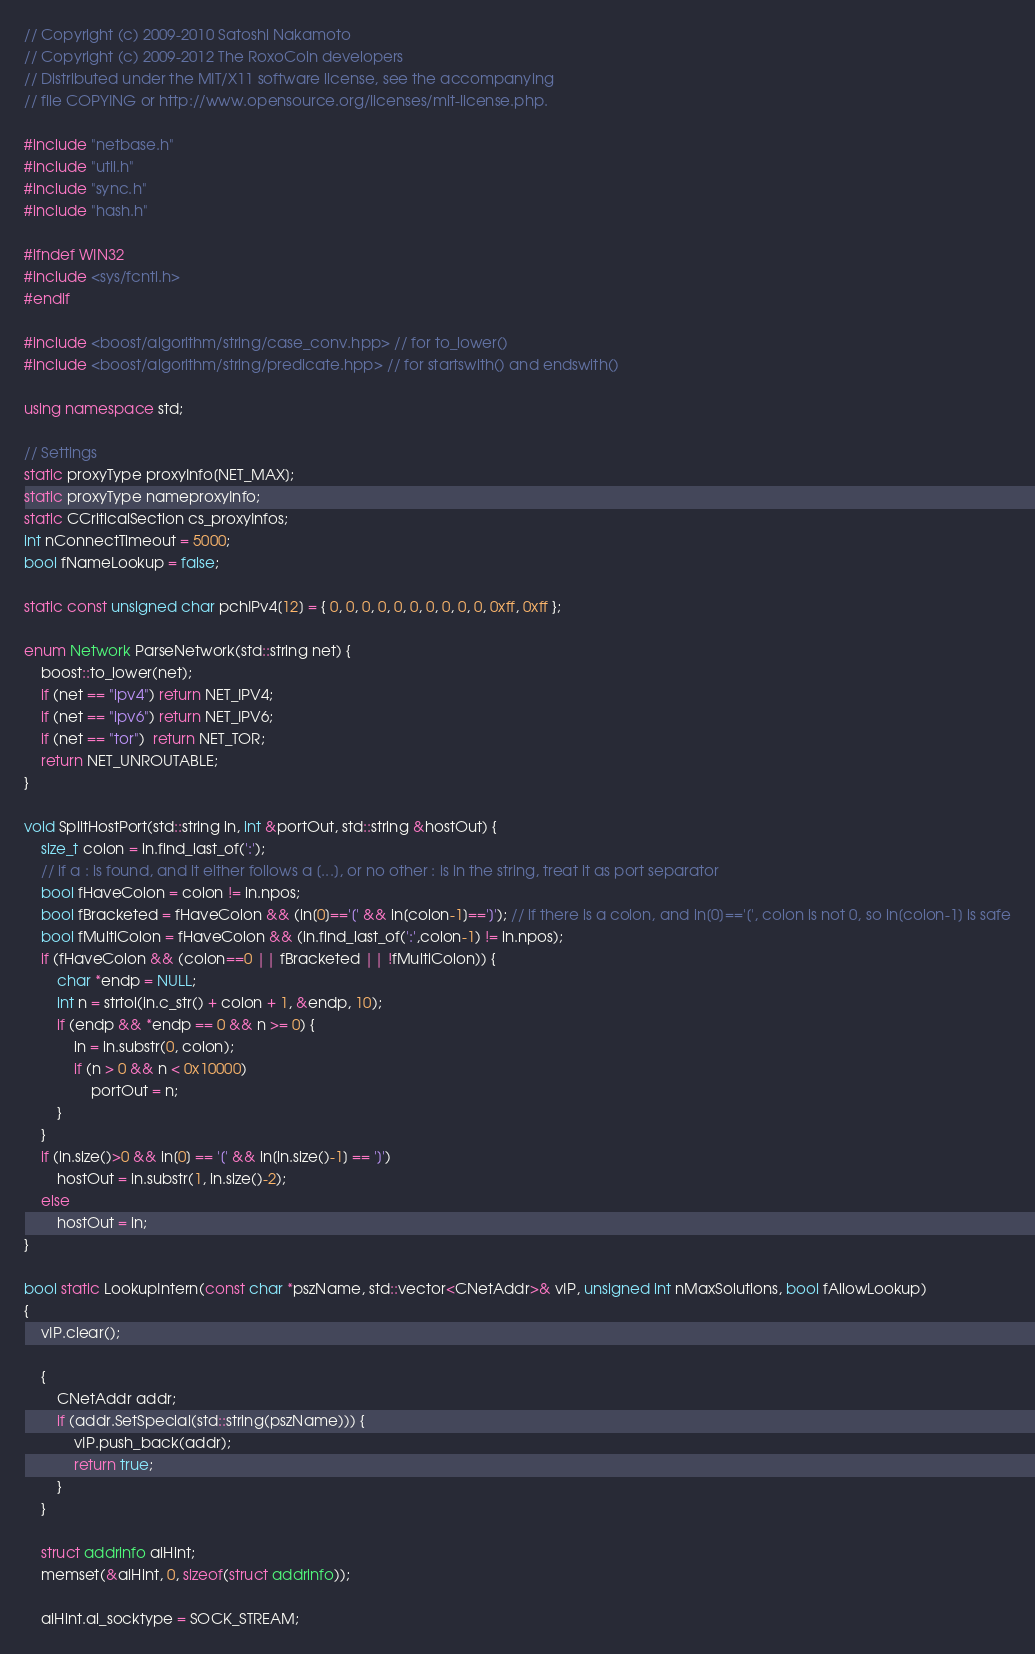Convert code to text. <code><loc_0><loc_0><loc_500><loc_500><_C++_>// Copyright (c) 2009-2010 Satoshi Nakamoto
// Copyright (c) 2009-2012 The RoxoCoin developers
// Distributed under the MIT/X11 software license, see the accompanying
// file COPYING or http://www.opensource.org/licenses/mit-license.php.

#include "netbase.h"
#include "util.h"
#include "sync.h"
#include "hash.h"

#ifndef WIN32
#include <sys/fcntl.h>
#endif

#include <boost/algorithm/string/case_conv.hpp> // for to_lower()
#include <boost/algorithm/string/predicate.hpp> // for startswith() and endswith()

using namespace std;

// Settings
static proxyType proxyInfo[NET_MAX];
static proxyType nameproxyInfo;
static CCriticalSection cs_proxyInfos;
int nConnectTimeout = 5000;
bool fNameLookup = false;

static const unsigned char pchIPv4[12] = { 0, 0, 0, 0, 0, 0, 0, 0, 0, 0, 0xff, 0xff };

enum Network ParseNetwork(std::string net) {
    boost::to_lower(net);
    if (net == "ipv4") return NET_IPV4;
    if (net == "ipv6") return NET_IPV6;
    if (net == "tor")  return NET_TOR;
    return NET_UNROUTABLE;
}

void SplitHostPort(std::string in, int &portOut, std::string &hostOut) {
    size_t colon = in.find_last_of(':');
    // if a : is found, and it either follows a [...], or no other : is in the string, treat it as port separator
    bool fHaveColon = colon != in.npos;
    bool fBracketed = fHaveColon && (in[0]=='[' && in[colon-1]==']'); // if there is a colon, and in[0]=='[', colon is not 0, so in[colon-1] is safe
    bool fMultiColon = fHaveColon && (in.find_last_of(':',colon-1) != in.npos);
    if (fHaveColon && (colon==0 || fBracketed || !fMultiColon)) {
        char *endp = NULL;
        int n = strtol(in.c_str() + colon + 1, &endp, 10);
        if (endp && *endp == 0 && n >= 0) {
            in = in.substr(0, colon);
            if (n > 0 && n < 0x10000)
                portOut = n;
        }
    }
    if (in.size()>0 && in[0] == '[' && in[in.size()-1] == ']')
        hostOut = in.substr(1, in.size()-2);
    else
        hostOut = in;
}

bool static LookupIntern(const char *pszName, std::vector<CNetAddr>& vIP, unsigned int nMaxSolutions, bool fAllowLookup)
{
    vIP.clear();

    {
        CNetAddr addr;
        if (addr.SetSpecial(std::string(pszName))) {
            vIP.push_back(addr);
            return true;
        }
    }

    struct addrinfo aiHint;
    memset(&aiHint, 0, sizeof(struct addrinfo));

    aiHint.ai_socktype = SOCK_STREAM;</code> 